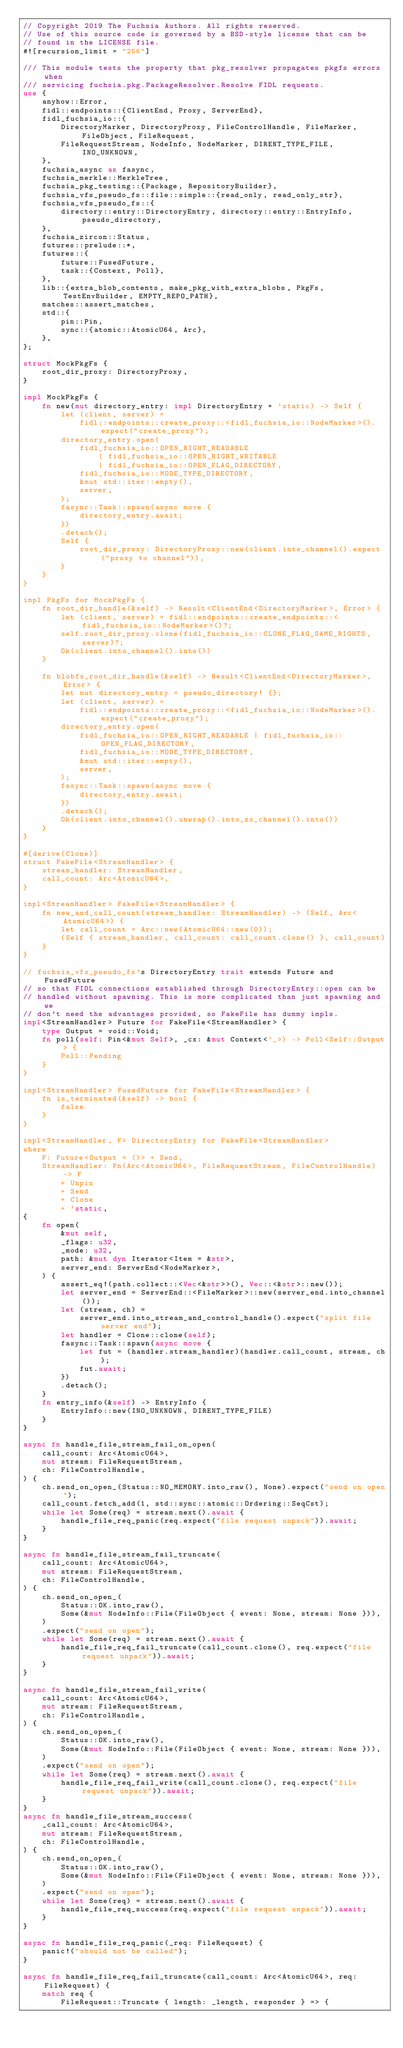<code> <loc_0><loc_0><loc_500><loc_500><_Rust_>// Copyright 2019 The Fuchsia Authors. All rights reserved.
// Use of this source code is governed by a BSD-style license that can be
// found in the LICENSE file.
#![recursion_limit = "256"]

/// This module tests the property that pkg_resolver propagates pkgfs errors when
/// servicing fuchsia.pkg.PackageResolver.Resolve FIDL requests.
use {
    anyhow::Error,
    fidl::endpoints::{ClientEnd, Proxy, ServerEnd},
    fidl_fuchsia_io::{
        DirectoryMarker, DirectoryProxy, FileControlHandle, FileMarker, FileObject, FileRequest,
        FileRequestStream, NodeInfo, NodeMarker, DIRENT_TYPE_FILE, INO_UNKNOWN,
    },
    fuchsia_async as fasync,
    fuchsia_merkle::MerkleTree,
    fuchsia_pkg_testing::{Package, RepositoryBuilder},
    fuchsia_vfs_pseudo_fs::file::simple::{read_only, read_only_str},
    fuchsia_vfs_pseudo_fs::{
        directory::entry::DirectoryEntry, directory::entry::EntryInfo, pseudo_directory,
    },
    fuchsia_zircon::Status,
    futures::prelude::*,
    futures::{
        future::FusedFuture,
        task::{Context, Poll},
    },
    lib::{extra_blob_contents, make_pkg_with_extra_blobs, PkgFs, TestEnvBuilder, EMPTY_REPO_PATH},
    matches::assert_matches,
    std::{
        pin::Pin,
        sync::{atomic::AtomicU64, Arc},
    },
};

struct MockPkgFs {
    root_dir_proxy: DirectoryProxy,
}

impl MockPkgFs {
    fn new(mut directory_entry: impl DirectoryEntry + 'static) -> Self {
        let (client, server) =
            fidl::endpoints::create_proxy::<fidl_fuchsia_io::NodeMarker>().expect("create_proxy");
        directory_entry.open(
            fidl_fuchsia_io::OPEN_RIGHT_READABLE
                | fidl_fuchsia_io::OPEN_RIGHT_WRITABLE
                | fidl_fuchsia_io::OPEN_FLAG_DIRECTORY,
            fidl_fuchsia_io::MODE_TYPE_DIRECTORY,
            &mut std::iter::empty(),
            server,
        );
        fasync::Task::spawn(async move {
            directory_entry.await;
        })
        .detach();
        Self {
            root_dir_proxy: DirectoryProxy::new(client.into_channel().expect("proxy to channel")),
        }
    }
}

impl PkgFs for MockPkgFs {
    fn root_dir_handle(&self) -> Result<ClientEnd<DirectoryMarker>, Error> {
        let (client, server) = fidl::endpoints::create_endpoints::<fidl_fuchsia_io::NodeMarker>()?;
        self.root_dir_proxy.clone(fidl_fuchsia_io::CLONE_FLAG_SAME_RIGHTS, server)?;
        Ok(client.into_channel().into())
    }

    fn blobfs_root_dir_handle(&self) -> Result<ClientEnd<DirectoryMarker>, Error> {
        let mut directory_entry = pseudo_directory! {};
        let (client, server) =
            fidl::endpoints::create_proxy::<fidl_fuchsia_io::NodeMarker>().expect("create_proxy");
        directory_entry.open(
            fidl_fuchsia_io::OPEN_RIGHT_READABLE | fidl_fuchsia_io::OPEN_FLAG_DIRECTORY,
            fidl_fuchsia_io::MODE_TYPE_DIRECTORY,
            &mut std::iter::empty(),
            server,
        );
        fasync::Task::spawn(async move {
            directory_entry.await;
        })
        .detach();
        Ok(client.into_channel().unwrap().into_zx_channel().into())
    }
}

#[derive(Clone)]
struct FakeFile<StreamHandler> {
    stream_handler: StreamHandler,
    call_count: Arc<AtomicU64>,
}

impl<StreamHandler> FakeFile<StreamHandler> {
    fn new_and_call_count(stream_handler: StreamHandler) -> (Self, Arc<AtomicU64>) {
        let call_count = Arc::new(AtomicU64::new(0));
        (Self { stream_handler, call_count: call_count.clone() }, call_count)
    }
}

// fuchsia_vfs_pseudo_fs's DirectoryEntry trait extends Future and FusedFuture
// so that FIDL connections established through DirectoryEntry::open can be
// handled without spawning. This is more complicated than just spawning and we
// don't need the advantages provided, so FakeFile has dummy impls.
impl<StreamHandler> Future for FakeFile<StreamHandler> {
    type Output = void::Void;
    fn poll(self: Pin<&mut Self>, _cx: &mut Context<'_>) -> Poll<Self::Output> {
        Poll::Pending
    }
}

impl<StreamHandler> FusedFuture for FakeFile<StreamHandler> {
    fn is_terminated(&self) -> bool {
        false
    }
}

impl<StreamHandler, F> DirectoryEntry for FakeFile<StreamHandler>
where
    F: Future<Output = ()> + Send,
    StreamHandler: Fn(Arc<AtomicU64>, FileRequestStream, FileControlHandle) -> F
        + Unpin
        + Send
        + Clone
        + 'static,
{
    fn open(
        &mut self,
        _flags: u32,
        _mode: u32,
        path: &mut dyn Iterator<Item = &str>,
        server_end: ServerEnd<NodeMarker>,
    ) {
        assert_eq!(path.collect::<Vec<&str>>(), Vec::<&str>::new());
        let server_end = ServerEnd::<FileMarker>::new(server_end.into_channel());
        let (stream, ch) =
            server_end.into_stream_and_control_handle().expect("split file server end");
        let handler = Clone::clone(self);
        fasync::Task::spawn(async move {
            let fut = (handler.stream_handler)(handler.call_count, stream, ch);
            fut.await;
        })
        .detach();
    }
    fn entry_info(&self) -> EntryInfo {
        EntryInfo::new(INO_UNKNOWN, DIRENT_TYPE_FILE)
    }
}

async fn handle_file_stream_fail_on_open(
    call_count: Arc<AtomicU64>,
    mut stream: FileRequestStream,
    ch: FileControlHandle,
) {
    ch.send_on_open_(Status::NO_MEMORY.into_raw(), None).expect("send on open");
    call_count.fetch_add(1, std::sync::atomic::Ordering::SeqCst);
    while let Some(req) = stream.next().await {
        handle_file_req_panic(req.expect("file request unpack")).await;
    }
}

async fn handle_file_stream_fail_truncate(
    call_count: Arc<AtomicU64>,
    mut stream: FileRequestStream,
    ch: FileControlHandle,
) {
    ch.send_on_open_(
        Status::OK.into_raw(),
        Some(&mut NodeInfo::File(FileObject { event: None, stream: None })),
    )
    .expect("send on open");
    while let Some(req) = stream.next().await {
        handle_file_req_fail_truncate(call_count.clone(), req.expect("file request unpack")).await;
    }
}

async fn handle_file_stream_fail_write(
    call_count: Arc<AtomicU64>,
    mut stream: FileRequestStream,
    ch: FileControlHandle,
) {
    ch.send_on_open_(
        Status::OK.into_raw(),
        Some(&mut NodeInfo::File(FileObject { event: None, stream: None })),
    )
    .expect("send on open");
    while let Some(req) = stream.next().await {
        handle_file_req_fail_write(call_count.clone(), req.expect("file request unpack")).await;
    }
}
async fn handle_file_stream_success(
    _call_count: Arc<AtomicU64>,
    mut stream: FileRequestStream,
    ch: FileControlHandle,
) {
    ch.send_on_open_(
        Status::OK.into_raw(),
        Some(&mut NodeInfo::File(FileObject { event: None, stream: None })),
    )
    .expect("send on open");
    while let Some(req) = stream.next().await {
        handle_file_req_success(req.expect("file request unpack")).await;
    }
}

async fn handle_file_req_panic(_req: FileRequest) {
    panic!("should not be called");
}

async fn handle_file_req_fail_truncate(call_count: Arc<AtomicU64>, req: FileRequest) {
    match req {
        FileRequest::Truncate { length: _length, responder } => {</code> 